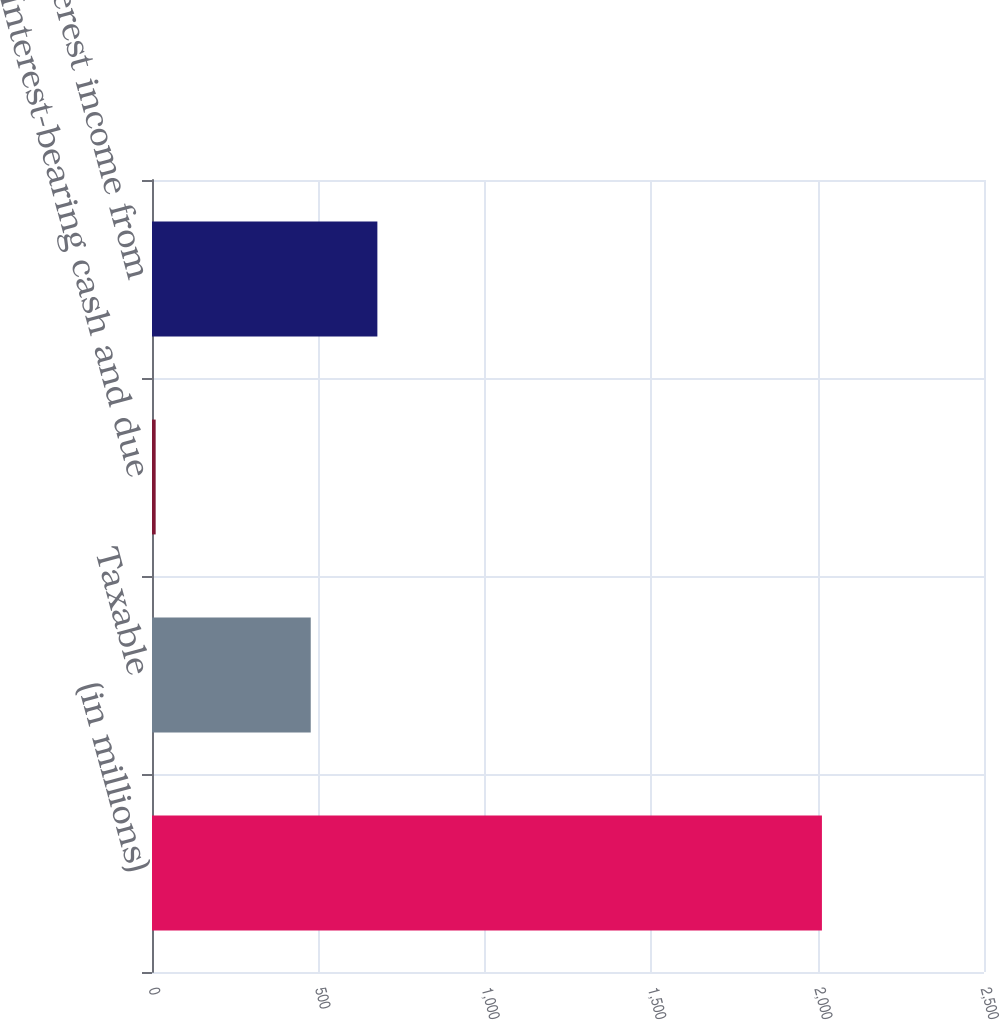Convert chart. <chart><loc_0><loc_0><loc_500><loc_500><bar_chart><fcel>(in millions)<fcel>Taxable<fcel>Interest-bearing cash and due<fcel>Total interest income from<nl><fcel>2013<fcel>477<fcel>11<fcel>677.2<nl></chart> 